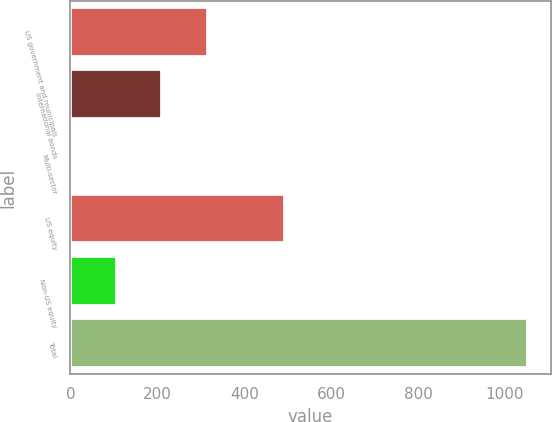<chart> <loc_0><loc_0><loc_500><loc_500><bar_chart><fcel>US government and municipals<fcel>International bonds<fcel>Multi-sector<fcel>US equity<fcel>Non-US equity<fcel>Total<nl><fcel>316.6<fcel>211.4<fcel>1<fcel>494<fcel>106.2<fcel>1053<nl></chart> 